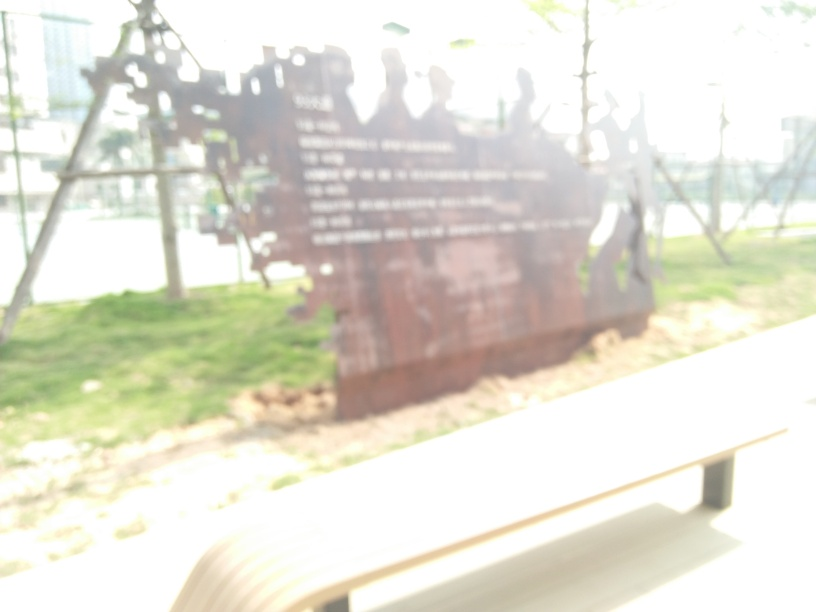What could be the reason for the blurriness of this image? The blurriness could be due to several reasons: the camera might have been out of focus, the photographer might have moved during the exposure, or it could be an intentional artistic choice to create an abstract effect. It's difficult to determine the exact cause without more context. 